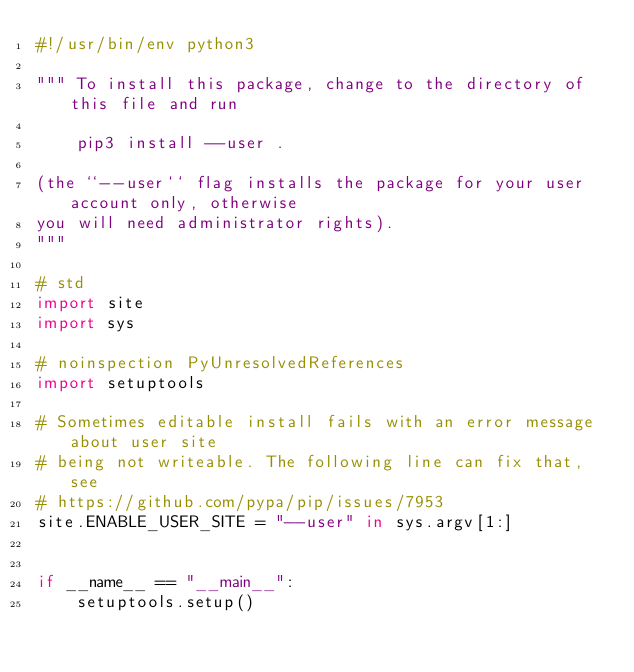Convert code to text. <code><loc_0><loc_0><loc_500><loc_500><_Python_>#!/usr/bin/env python3

""" To install this package, change to the directory of this file and run

    pip3 install --user .

(the ``--user`` flag installs the package for your user account only, otherwise
you will need administrator rights).
"""

# std
import site
import sys

# noinspection PyUnresolvedReferences
import setuptools

# Sometimes editable install fails with an error message about user site
# being not writeable. The following line can fix that, see
# https://github.com/pypa/pip/issues/7953
site.ENABLE_USER_SITE = "--user" in sys.argv[1:]


if __name__ == "__main__":
    setuptools.setup()
</code> 